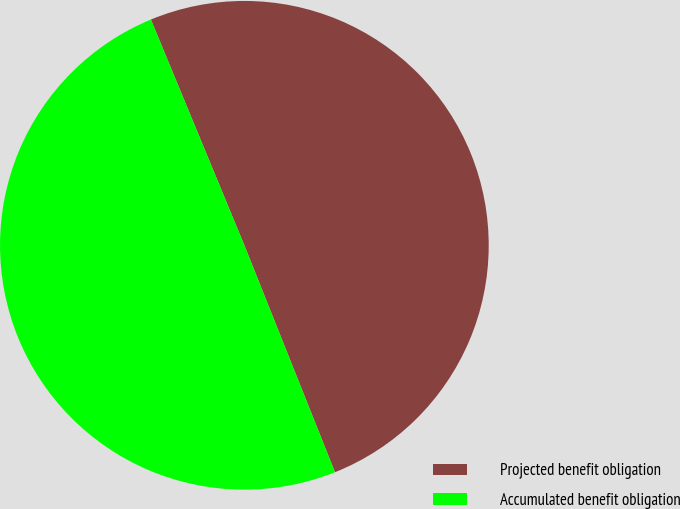Convert chart. <chart><loc_0><loc_0><loc_500><loc_500><pie_chart><fcel>Projected benefit obligation<fcel>Accumulated benefit obligation<nl><fcel>50.2%<fcel>49.8%<nl></chart> 